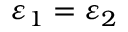Convert formula to latex. <formula><loc_0><loc_0><loc_500><loc_500>\varepsilon _ { 1 } = \varepsilon _ { 2 }</formula> 